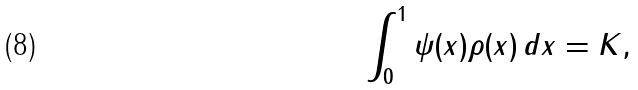Convert formula to latex. <formula><loc_0><loc_0><loc_500><loc_500>\int _ { 0 } ^ { 1 } \psi ( x ) \rho ( x ) \, d x = K ,</formula> 